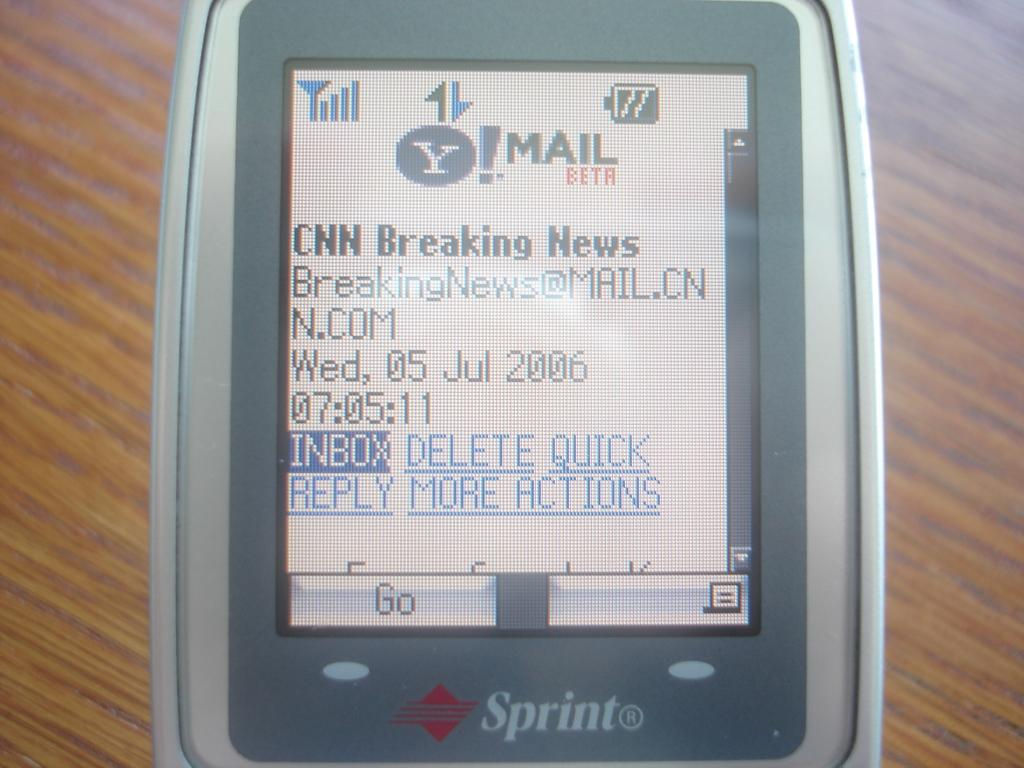<image>
Summarize the visual content of the image. A Sprint device showing Yahoo mail on the screen. 